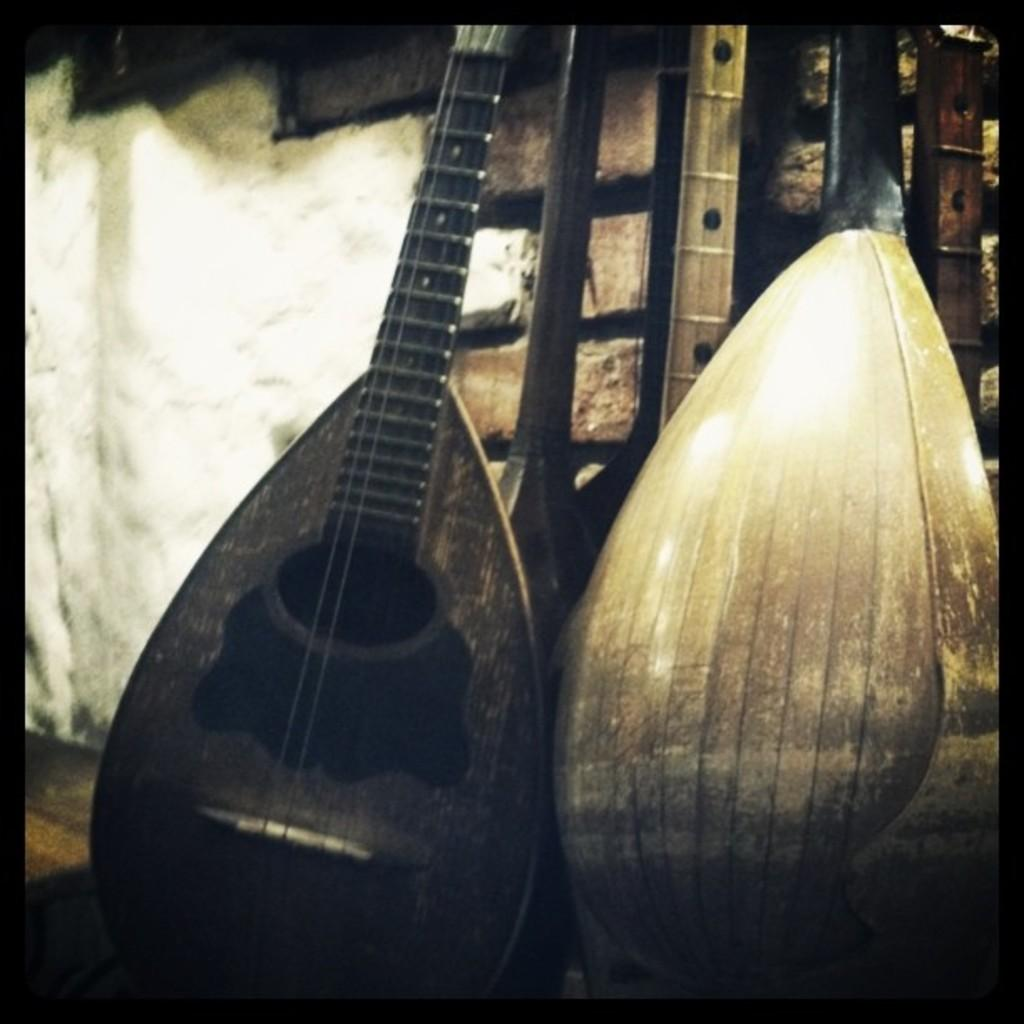What type of musical instruments are in the image? There are guitars in the image. Where are the guitars located in relation to the wall? The guitars are near a brick wall. What type of flooring is visible in the image? There is a wooden floor visible in the bottom left of the image. What type of headwear is the tree wearing in the image? There is no tree present in the image, and therefore no headwear can be observed. 